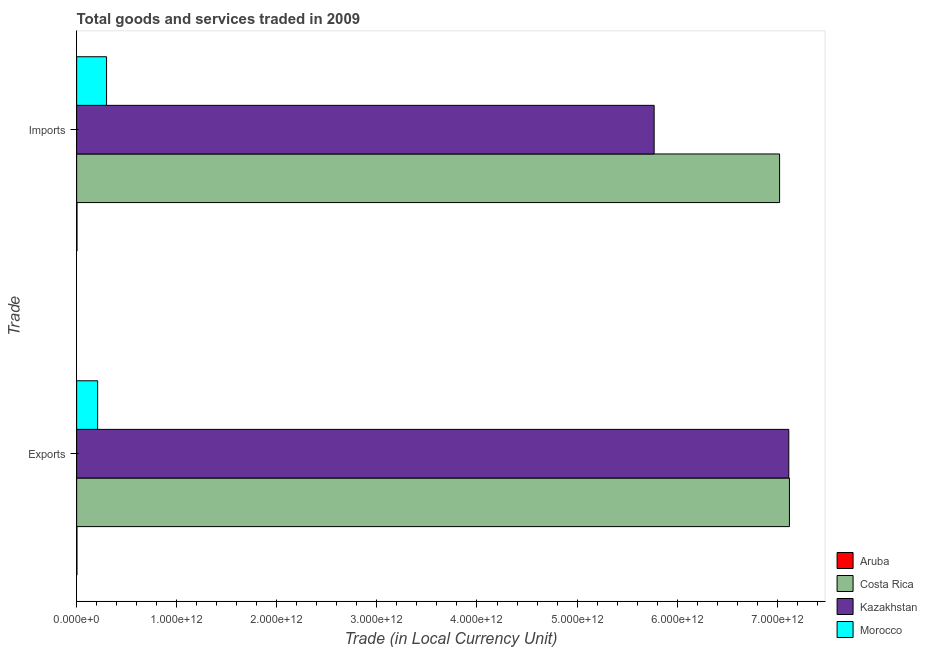Are the number of bars per tick equal to the number of legend labels?
Offer a very short reply. Yes. Are the number of bars on each tick of the Y-axis equal?
Ensure brevity in your answer.  Yes. How many bars are there on the 2nd tick from the top?
Keep it short and to the point. 4. What is the label of the 2nd group of bars from the top?
Make the answer very short. Exports. What is the export of goods and services in Morocco?
Provide a short and direct response. 2.10e+11. Across all countries, what is the maximum export of goods and services?
Provide a succinct answer. 7.12e+12. Across all countries, what is the minimum imports of goods and services?
Ensure brevity in your answer.  3.41e+09. In which country was the export of goods and services minimum?
Your response must be concise. Aruba. What is the total imports of goods and services in the graph?
Offer a very short reply. 1.31e+13. What is the difference between the export of goods and services in Costa Rica and that in Aruba?
Offer a very short reply. 7.12e+12. What is the difference between the imports of goods and services in Aruba and the export of goods and services in Costa Rica?
Your answer should be compact. -7.12e+12. What is the average imports of goods and services per country?
Your response must be concise. 3.27e+12. What is the difference between the export of goods and services and imports of goods and services in Costa Rica?
Give a very brief answer. 9.83e+1. What is the ratio of the imports of goods and services in Kazakhstan to that in Costa Rica?
Keep it short and to the point. 0.82. In how many countries, is the imports of goods and services greater than the average imports of goods and services taken over all countries?
Offer a terse response. 2. What does the 3rd bar from the top in Exports represents?
Offer a terse response. Costa Rica. What does the 4th bar from the bottom in Imports represents?
Your answer should be compact. Morocco. How many countries are there in the graph?
Give a very brief answer. 4. What is the difference between two consecutive major ticks on the X-axis?
Offer a very short reply. 1.00e+12. Does the graph contain grids?
Offer a very short reply. No. Where does the legend appear in the graph?
Your response must be concise. Bottom right. How many legend labels are there?
Your response must be concise. 4. What is the title of the graph?
Offer a very short reply. Total goods and services traded in 2009. What is the label or title of the X-axis?
Offer a very short reply. Trade (in Local Currency Unit). What is the label or title of the Y-axis?
Your answer should be very brief. Trade. What is the Trade (in Local Currency Unit) of Aruba in Exports?
Ensure brevity in your answer.  2.85e+09. What is the Trade (in Local Currency Unit) in Costa Rica in Exports?
Give a very brief answer. 7.12e+12. What is the Trade (in Local Currency Unit) in Kazakhstan in Exports?
Offer a terse response. 7.12e+12. What is the Trade (in Local Currency Unit) of Morocco in Exports?
Your answer should be compact. 2.10e+11. What is the Trade (in Local Currency Unit) in Aruba in Imports?
Your answer should be compact. 3.41e+09. What is the Trade (in Local Currency Unit) of Costa Rica in Imports?
Your answer should be very brief. 7.02e+12. What is the Trade (in Local Currency Unit) in Kazakhstan in Imports?
Keep it short and to the point. 5.77e+12. What is the Trade (in Local Currency Unit) in Morocco in Imports?
Provide a succinct answer. 2.99e+11. Across all Trade, what is the maximum Trade (in Local Currency Unit) in Aruba?
Your response must be concise. 3.41e+09. Across all Trade, what is the maximum Trade (in Local Currency Unit) of Costa Rica?
Provide a short and direct response. 7.12e+12. Across all Trade, what is the maximum Trade (in Local Currency Unit) of Kazakhstan?
Ensure brevity in your answer.  7.12e+12. Across all Trade, what is the maximum Trade (in Local Currency Unit) in Morocco?
Your answer should be compact. 2.99e+11. Across all Trade, what is the minimum Trade (in Local Currency Unit) of Aruba?
Keep it short and to the point. 2.85e+09. Across all Trade, what is the minimum Trade (in Local Currency Unit) in Costa Rica?
Your answer should be compact. 7.02e+12. Across all Trade, what is the minimum Trade (in Local Currency Unit) in Kazakhstan?
Give a very brief answer. 5.77e+12. Across all Trade, what is the minimum Trade (in Local Currency Unit) in Morocco?
Offer a very short reply. 2.10e+11. What is the total Trade (in Local Currency Unit) of Aruba in the graph?
Provide a succinct answer. 6.27e+09. What is the total Trade (in Local Currency Unit) in Costa Rica in the graph?
Your answer should be very brief. 1.41e+13. What is the total Trade (in Local Currency Unit) of Kazakhstan in the graph?
Offer a very short reply. 1.29e+13. What is the total Trade (in Local Currency Unit) in Morocco in the graph?
Give a very brief answer. 5.08e+11. What is the difference between the Trade (in Local Currency Unit) in Aruba in Exports and that in Imports?
Your answer should be very brief. -5.59e+08. What is the difference between the Trade (in Local Currency Unit) in Costa Rica in Exports and that in Imports?
Your answer should be compact. 9.83e+1. What is the difference between the Trade (in Local Currency Unit) in Kazakhstan in Exports and that in Imports?
Provide a short and direct response. 1.35e+12. What is the difference between the Trade (in Local Currency Unit) of Morocco in Exports and that in Imports?
Offer a terse response. -8.91e+1. What is the difference between the Trade (in Local Currency Unit) in Aruba in Exports and the Trade (in Local Currency Unit) in Costa Rica in Imports?
Your answer should be very brief. -7.02e+12. What is the difference between the Trade (in Local Currency Unit) of Aruba in Exports and the Trade (in Local Currency Unit) of Kazakhstan in Imports?
Make the answer very short. -5.77e+12. What is the difference between the Trade (in Local Currency Unit) in Aruba in Exports and the Trade (in Local Currency Unit) in Morocco in Imports?
Provide a short and direct response. -2.96e+11. What is the difference between the Trade (in Local Currency Unit) in Costa Rica in Exports and the Trade (in Local Currency Unit) in Kazakhstan in Imports?
Your answer should be compact. 1.35e+12. What is the difference between the Trade (in Local Currency Unit) of Costa Rica in Exports and the Trade (in Local Currency Unit) of Morocco in Imports?
Offer a very short reply. 6.82e+12. What is the difference between the Trade (in Local Currency Unit) of Kazakhstan in Exports and the Trade (in Local Currency Unit) of Morocco in Imports?
Keep it short and to the point. 6.82e+12. What is the average Trade (in Local Currency Unit) of Aruba per Trade?
Provide a succinct answer. 3.13e+09. What is the average Trade (in Local Currency Unit) of Costa Rica per Trade?
Your answer should be very brief. 7.07e+12. What is the average Trade (in Local Currency Unit) of Kazakhstan per Trade?
Make the answer very short. 6.44e+12. What is the average Trade (in Local Currency Unit) in Morocco per Trade?
Offer a very short reply. 2.54e+11. What is the difference between the Trade (in Local Currency Unit) of Aruba and Trade (in Local Currency Unit) of Costa Rica in Exports?
Provide a short and direct response. -7.12e+12. What is the difference between the Trade (in Local Currency Unit) in Aruba and Trade (in Local Currency Unit) in Kazakhstan in Exports?
Provide a short and direct response. -7.11e+12. What is the difference between the Trade (in Local Currency Unit) in Aruba and Trade (in Local Currency Unit) in Morocco in Exports?
Ensure brevity in your answer.  -2.07e+11. What is the difference between the Trade (in Local Currency Unit) in Costa Rica and Trade (in Local Currency Unit) in Kazakhstan in Exports?
Your answer should be very brief. 6.29e+09. What is the difference between the Trade (in Local Currency Unit) of Costa Rica and Trade (in Local Currency Unit) of Morocco in Exports?
Offer a terse response. 6.91e+12. What is the difference between the Trade (in Local Currency Unit) of Kazakhstan and Trade (in Local Currency Unit) of Morocco in Exports?
Provide a short and direct response. 6.91e+12. What is the difference between the Trade (in Local Currency Unit) in Aruba and Trade (in Local Currency Unit) in Costa Rica in Imports?
Give a very brief answer. -7.02e+12. What is the difference between the Trade (in Local Currency Unit) in Aruba and Trade (in Local Currency Unit) in Kazakhstan in Imports?
Offer a terse response. -5.77e+12. What is the difference between the Trade (in Local Currency Unit) in Aruba and Trade (in Local Currency Unit) in Morocco in Imports?
Provide a succinct answer. -2.95e+11. What is the difference between the Trade (in Local Currency Unit) in Costa Rica and Trade (in Local Currency Unit) in Kazakhstan in Imports?
Your answer should be very brief. 1.25e+12. What is the difference between the Trade (in Local Currency Unit) of Costa Rica and Trade (in Local Currency Unit) of Morocco in Imports?
Keep it short and to the point. 6.72e+12. What is the difference between the Trade (in Local Currency Unit) of Kazakhstan and Trade (in Local Currency Unit) of Morocco in Imports?
Your answer should be compact. 5.47e+12. What is the ratio of the Trade (in Local Currency Unit) in Aruba in Exports to that in Imports?
Your answer should be compact. 0.84. What is the ratio of the Trade (in Local Currency Unit) of Kazakhstan in Exports to that in Imports?
Provide a succinct answer. 1.23. What is the ratio of the Trade (in Local Currency Unit) in Morocco in Exports to that in Imports?
Make the answer very short. 0.7. What is the difference between the highest and the second highest Trade (in Local Currency Unit) of Aruba?
Make the answer very short. 5.59e+08. What is the difference between the highest and the second highest Trade (in Local Currency Unit) of Costa Rica?
Your answer should be very brief. 9.83e+1. What is the difference between the highest and the second highest Trade (in Local Currency Unit) of Kazakhstan?
Ensure brevity in your answer.  1.35e+12. What is the difference between the highest and the second highest Trade (in Local Currency Unit) of Morocco?
Make the answer very short. 8.91e+1. What is the difference between the highest and the lowest Trade (in Local Currency Unit) of Aruba?
Offer a terse response. 5.59e+08. What is the difference between the highest and the lowest Trade (in Local Currency Unit) of Costa Rica?
Give a very brief answer. 9.83e+1. What is the difference between the highest and the lowest Trade (in Local Currency Unit) of Kazakhstan?
Provide a short and direct response. 1.35e+12. What is the difference between the highest and the lowest Trade (in Local Currency Unit) of Morocco?
Offer a terse response. 8.91e+1. 